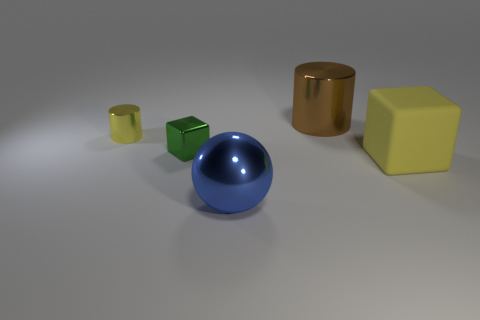Add 4 green objects. How many objects exist? 9 Subtract 1 blocks. How many blocks are left? 1 Subtract all balls. How many objects are left? 4 Add 4 small yellow cylinders. How many small yellow cylinders are left? 5 Add 4 cubes. How many cubes exist? 6 Subtract 0 brown cubes. How many objects are left? 5 Subtract all red cubes. Subtract all purple spheres. How many cubes are left? 2 Subtract all big brown metallic cylinders. Subtract all blue things. How many objects are left? 3 